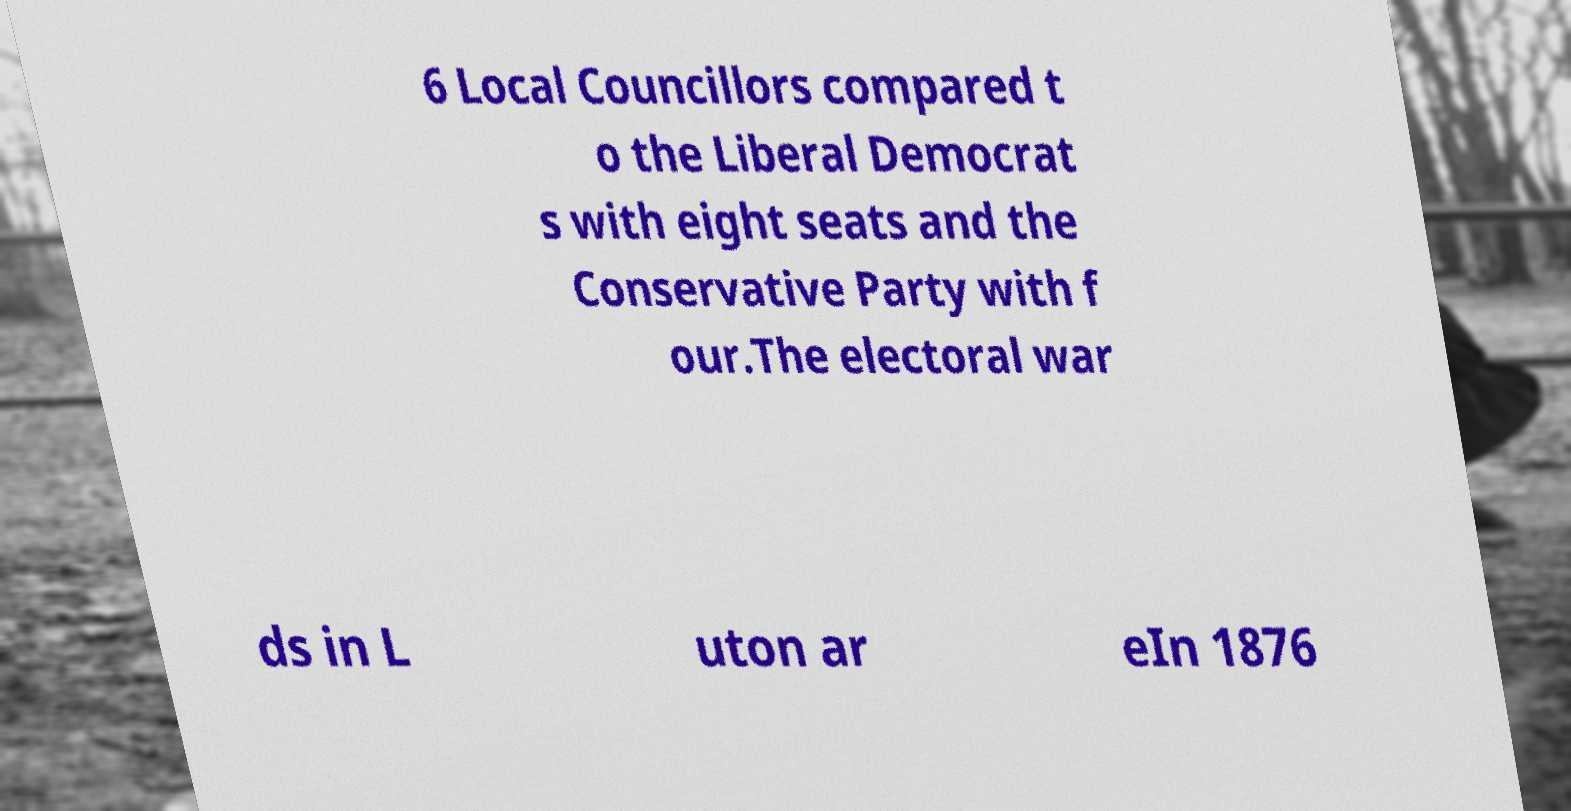Could you extract and type out the text from this image? 6 Local Councillors compared t o the Liberal Democrat s with eight seats and the Conservative Party with f our.The electoral war ds in L uton ar eIn 1876 